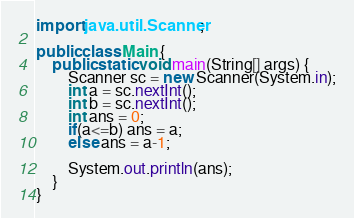Convert code to text. <code><loc_0><loc_0><loc_500><loc_500><_Java_>import java.util.Scanner;

public class Main {
    public static void main(String[] args) {
        Scanner sc = new Scanner(System.in);
        int a = sc.nextInt();
        int b = sc.nextInt();
        int ans = 0;
        if(a<=b) ans = a;
        else ans = a-1;

        System.out.println(ans);
    }
}</code> 